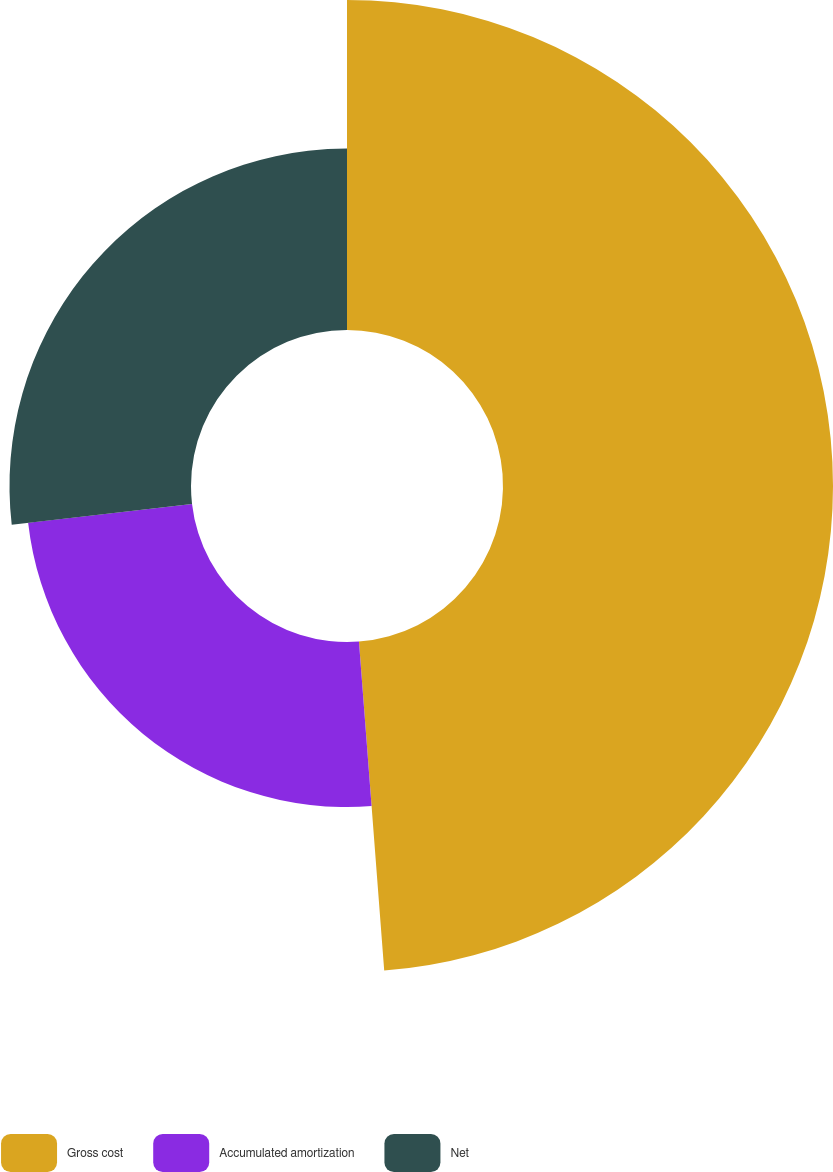Convert chart. <chart><loc_0><loc_0><loc_500><loc_500><pie_chart><fcel>Gross cost<fcel>Accumulated amortization<fcel>Net<nl><fcel>48.78%<fcel>24.39%<fcel>26.83%<nl></chart> 